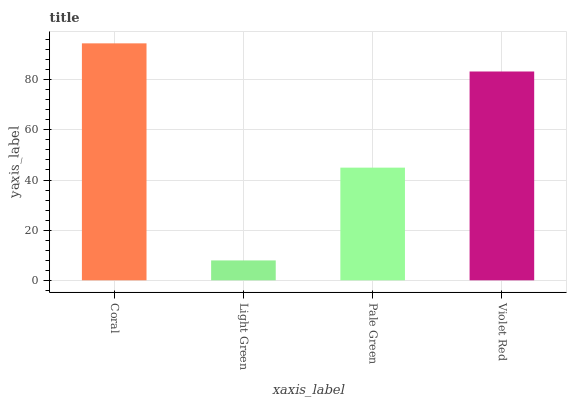Is Pale Green the minimum?
Answer yes or no. No. Is Pale Green the maximum?
Answer yes or no. No. Is Pale Green greater than Light Green?
Answer yes or no. Yes. Is Light Green less than Pale Green?
Answer yes or no. Yes. Is Light Green greater than Pale Green?
Answer yes or no. No. Is Pale Green less than Light Green?
Answer yes or no. No. Is Violet Red the high median?
Answer yes or no. Yes. Is Pale Green the low median?
Answer yes or no. Yes. Is Coral the high median?
Answer yes or no. No. Is Violet Red the low median?
Answer yes or no. No. 